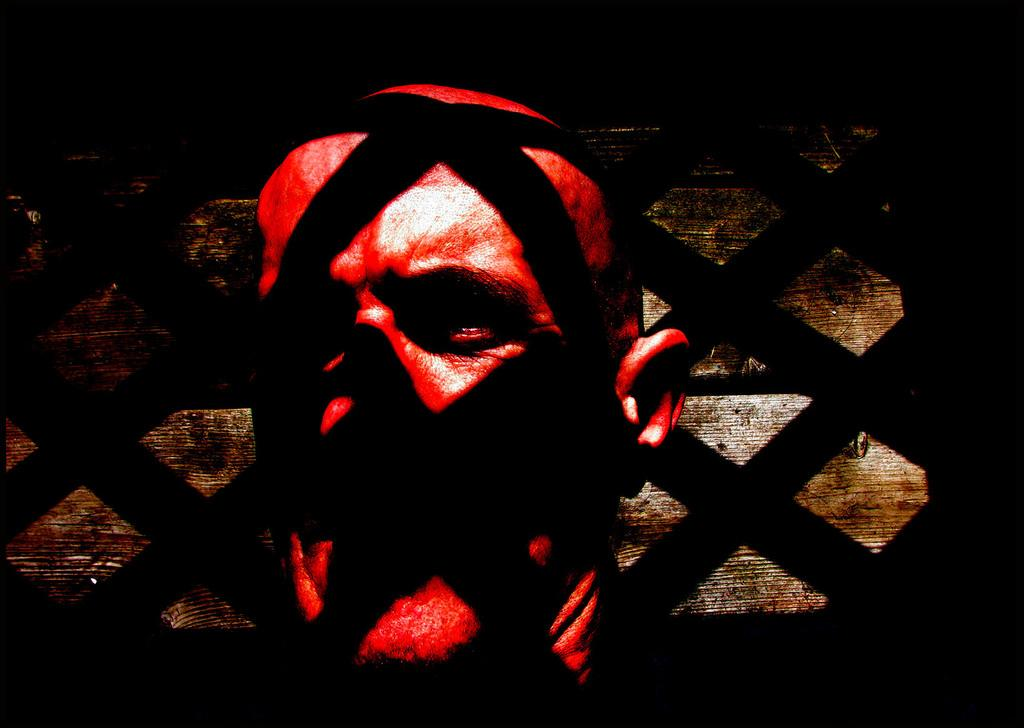What is the main subject of the image? The main subject of the image is the face of a person. What is a noticeable feature of the face in the image? The face has red paint on it. Can you describe any other elements in the image related to the face? There is a black shadow falling on the face. What type of railway engine can be seen in the image? There is no railway engine present in the image; it features the face of a person with red paint and a black shadow. 